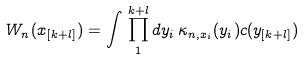Convert formula to latex. <formula><loc_0><loc_0><loc_500><loc_500>W _ { n } ( x _ { [ k + l ] } ) = \int \, \prod _ { 1 } ^ { k + l } d y _ { i } \, \kappa _ { n , x _ { i } } ( y _ { i } ) c ( y _ { [ k + l ] } )</formula> 